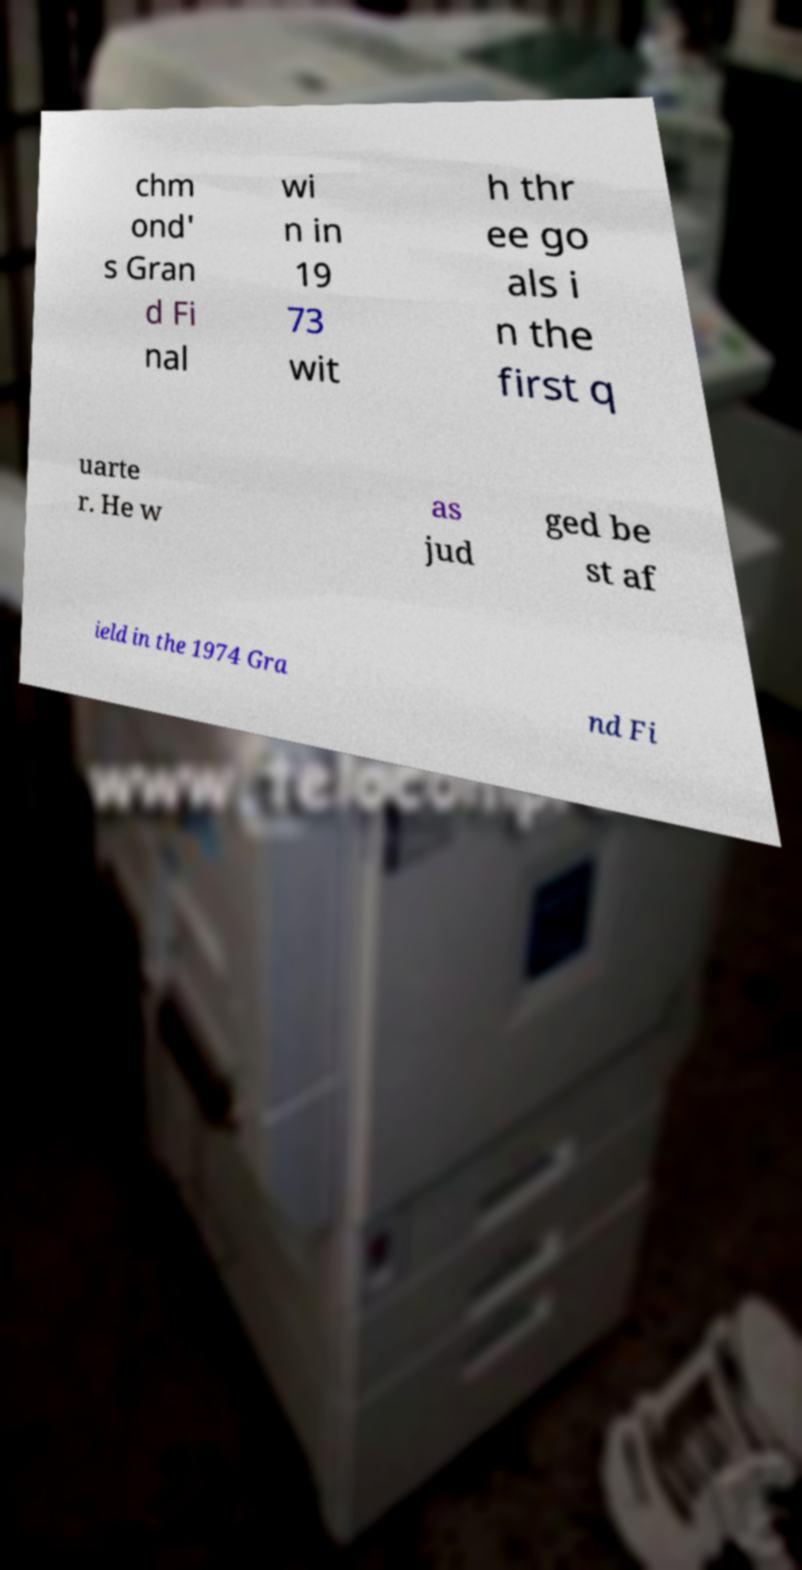Could you assist in decoding the text presented in this image and type it out clearly? chm ond' s Gran d Fi nal wi n in 19 73 wit h thr ee go als i n the first q uarte r. He w as jud ged be st af ield in the 1974 Gra nd Fi 